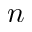Convert formula to latex. <formula><loc_0><loc_0><loc_500><loc_500>n</formula> 